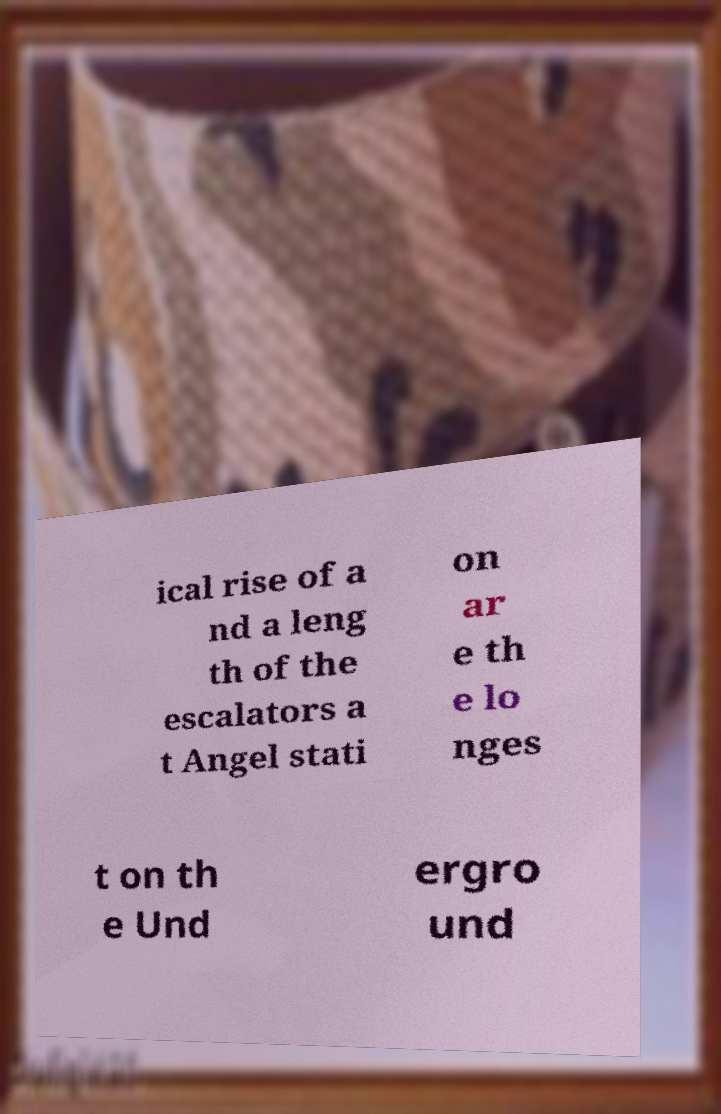For documentation purposes, I need the text within this image transcribed. Could you provide that? ical rise of a nd a leng th of the escalators a t Angel stati on ar e th e lo nges t on th e Und ergro und 